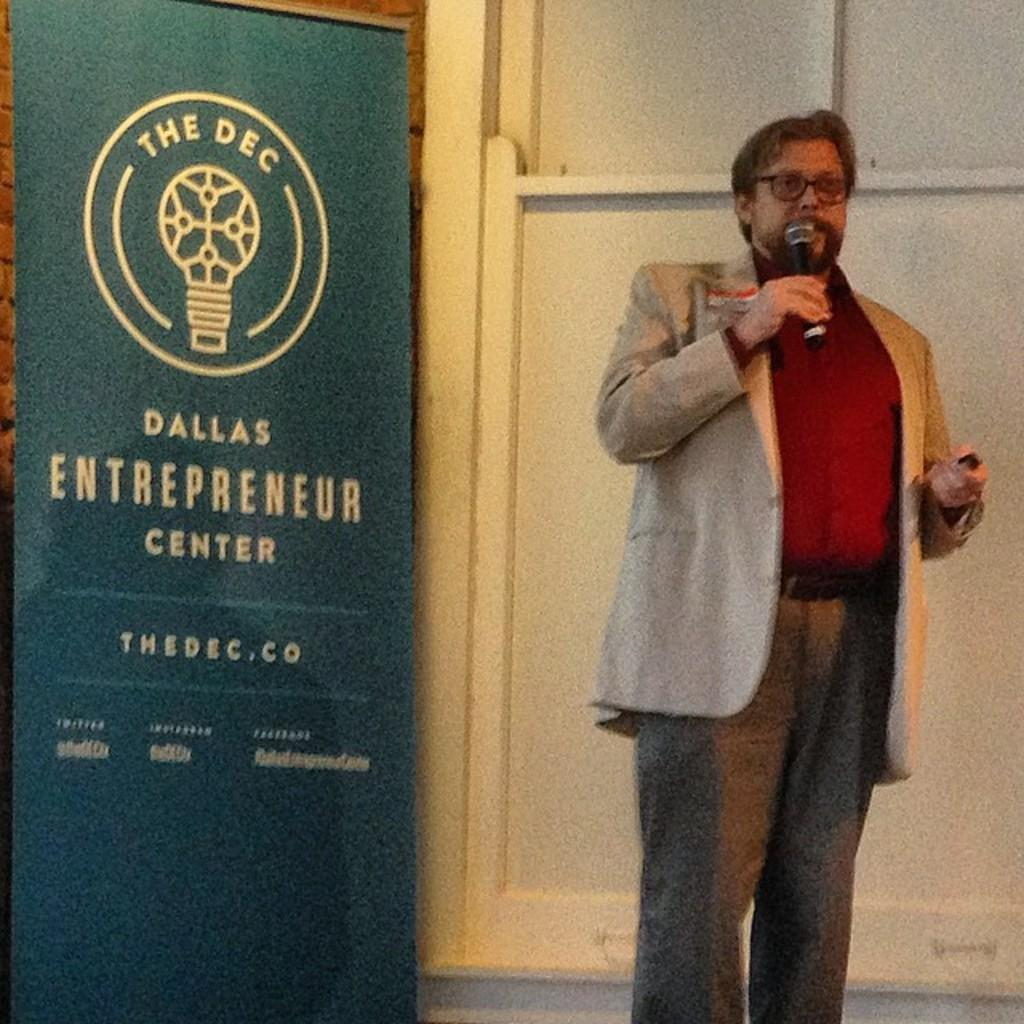<image>
Relay a brief, clear account of the picture shown. a man that is speaking next to a dallas entrepreneur sign 